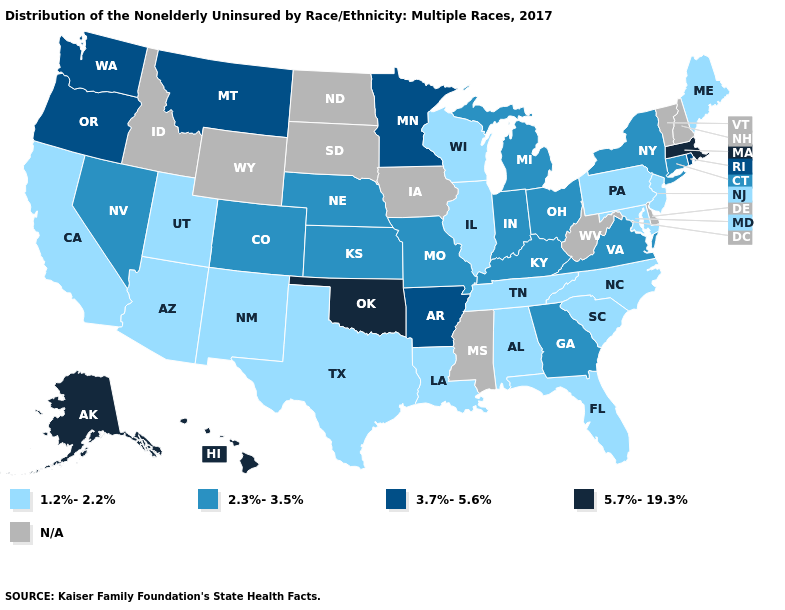Name the states that have a value in the range 3.7%-5.6%?
Quick response, please. Arkansas, Minnesota, Montana, Oregon, Rhode Island, Washington. What is the value of Washington?
Short answer required. 3.7%-5.6%. What is the lowest value in the USA?
Answer briefly. 1.2%-2.2%. What is the value of Kansas?
Keep it brief. 2.3%-3.5%. Does New Jersey have the highest value in the Northeast?
Write a very short answer. No. Among the states that border Florida , which have the lowest value?
Write a very short answer. Alabama. Does Virginia have the lowest value in the USA?
Keep it brief. No. What is the value of South Dakota?
Give a very brief answer. N/A. Among the states that border New York , does Connecticut have the lowest value?
Write a very short answer. No. Is the legend a continuous bar?
Concise answer only. No. What is the value of Kansas?
Be succinct. 2.3%-3.5%. What is the value of Michigan?
Answer briefly. 2.3%-3.5%. What is the value of Arkansas?
Keep it brief. 3.7%-5.6%. What is the value of South Carolina?
Concise answer only. 1.2%-2.2%. Is the legend a continuous bar?
Be succinct. No. 